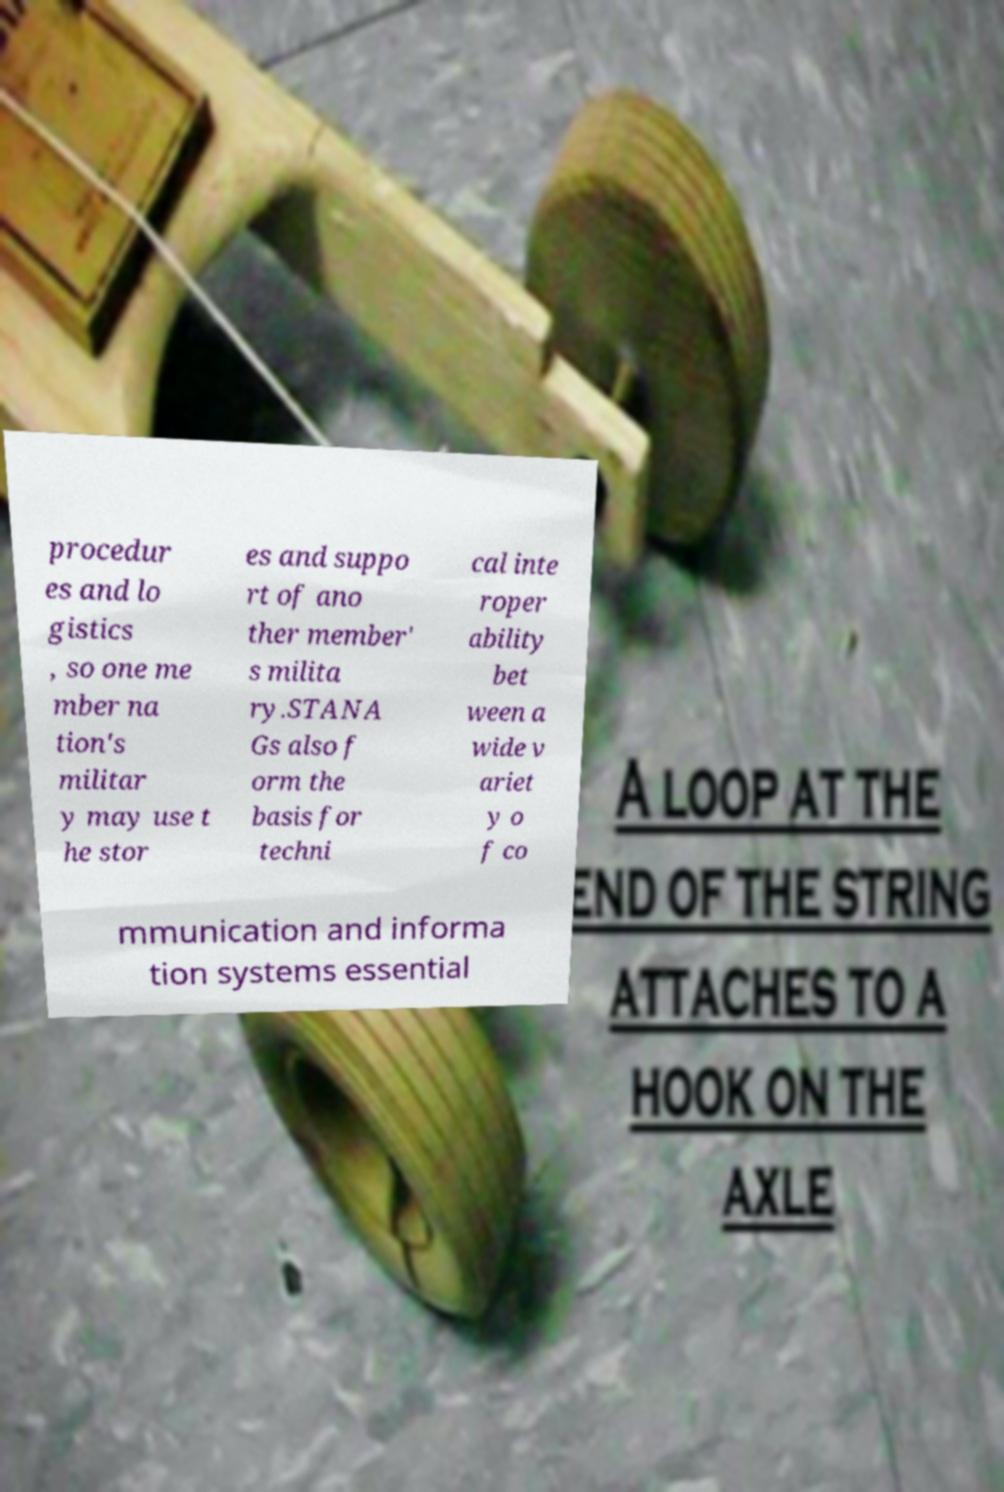For documentation purposes, I need the text within this image transcribed. Could you provide that? procedur es and lo gistics , so one me mber na tion's militar y may use t he stor es and suppo rt of ano ther member' s milita ry.STANA Gs also f orm the basis for techni cal inte roper ability bet ween a wide v ariet y o f co mmunication and informa tion systems essential 